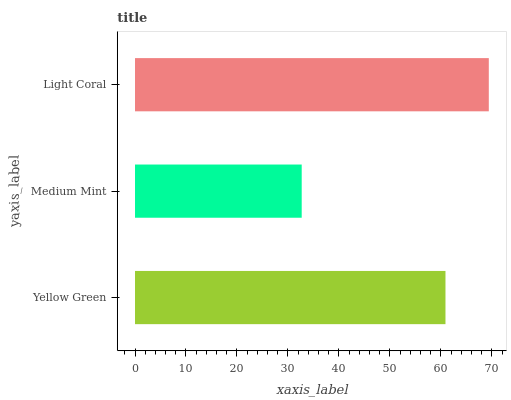Is Medium Mint the minimum?
Answer yes or no. Yes. Is Light Coral the maximum?
Answer yes or no. Yes. Is Light Coral the minimum?
Answer yes or no. No. Is Medium Mint the maximum?
Answer yes or no. No. Is Light Coral greater than Medium Mint?
Answer yes or no. Yes. Is Medium Mint less than Light Coral?
Answer yes or no. Yes. Is Medium Mint greater than Light Coral?
Answer yes or no. No. Is Light Coral less than Medium Mint?
Answer yes or no. No. Is Yellow Green the high median?
Answer yes or no. Yes. Is Yellow Green the low median?
Answer yes or no. Yes. Is Medium Mint the high median?
Answer yes or no. No. Is Medium Mint the low median?
Answer yes or no. No. 